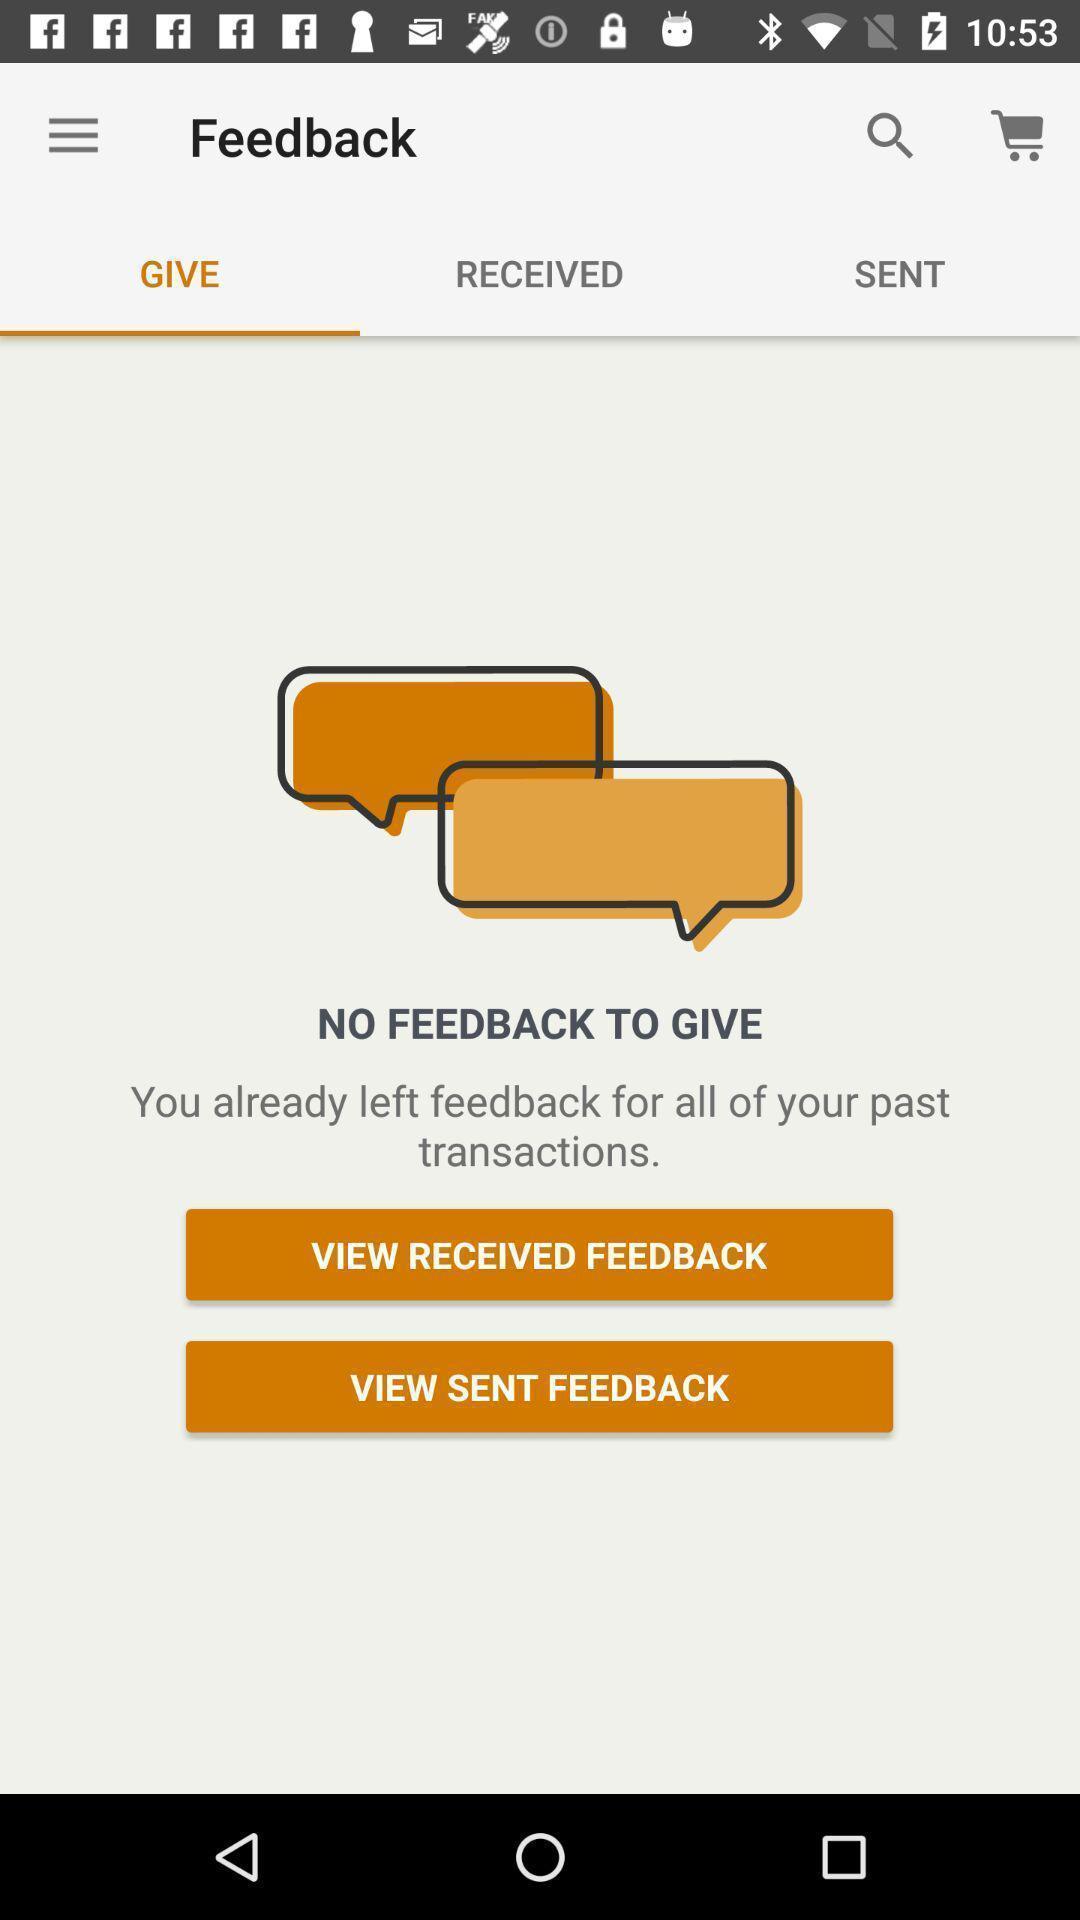Provide a textual representation of this image. Screen shows feedback details in a shopping application. 